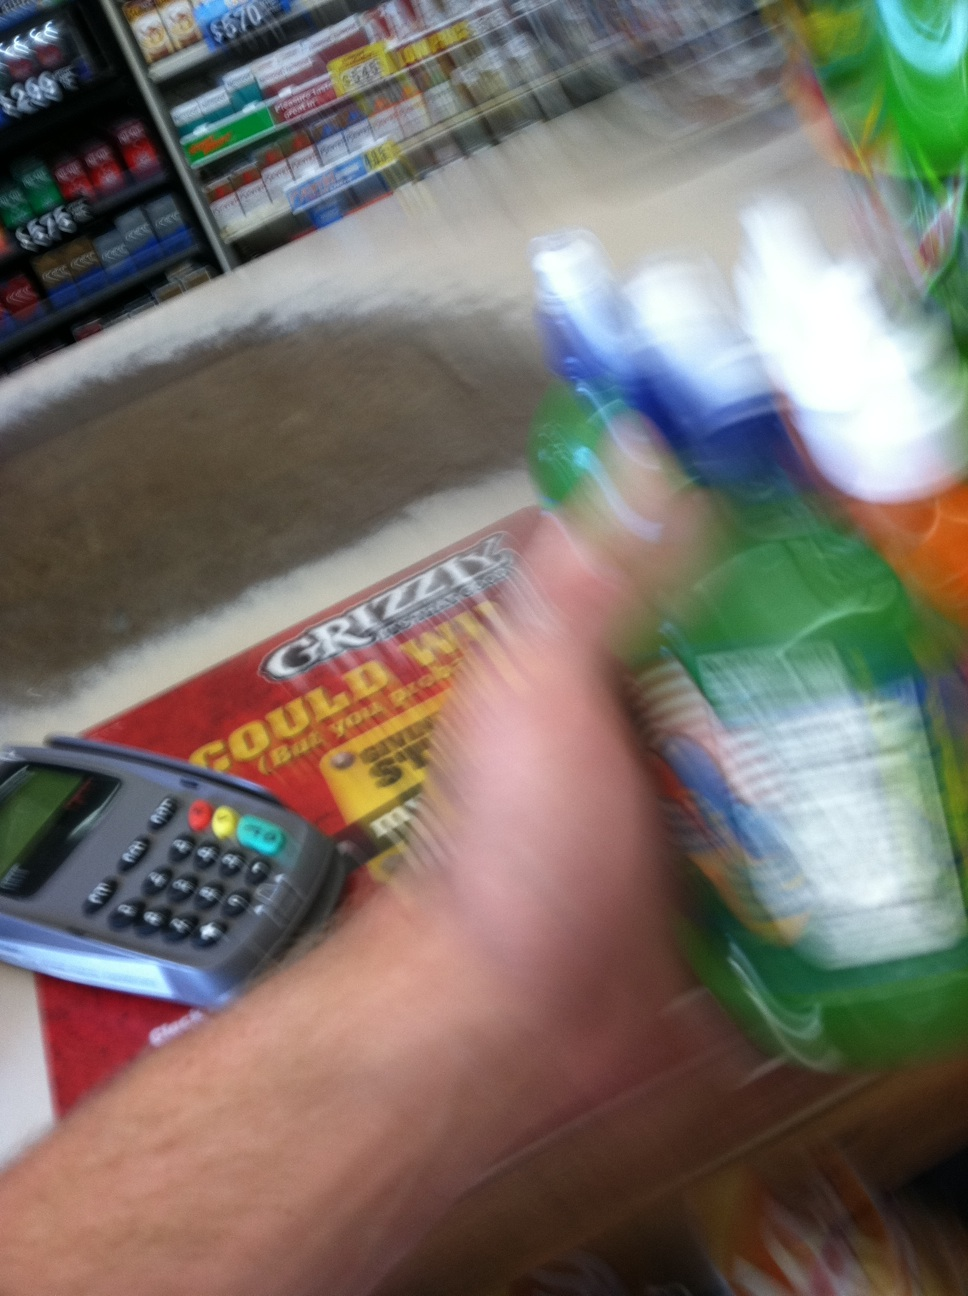What does the advertisement on the counter suggest about the store's location? The advertisement mentions 'Grizzly', which is a brand associated with smokeless tobacco products. This suggests that the store could be located in a region where such products are popularly sold, likely in the United States. What does the presence of a card payment machine indicate about the store? The presence of a card payment machine indicates that the store accommodates modern payment methods, allowing for electronic transactions, which is typical in many retail environments today for customer convenience. 